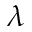<formula> <loc_0><loc_0><loc_500><loc_500>\lambda</formula> 